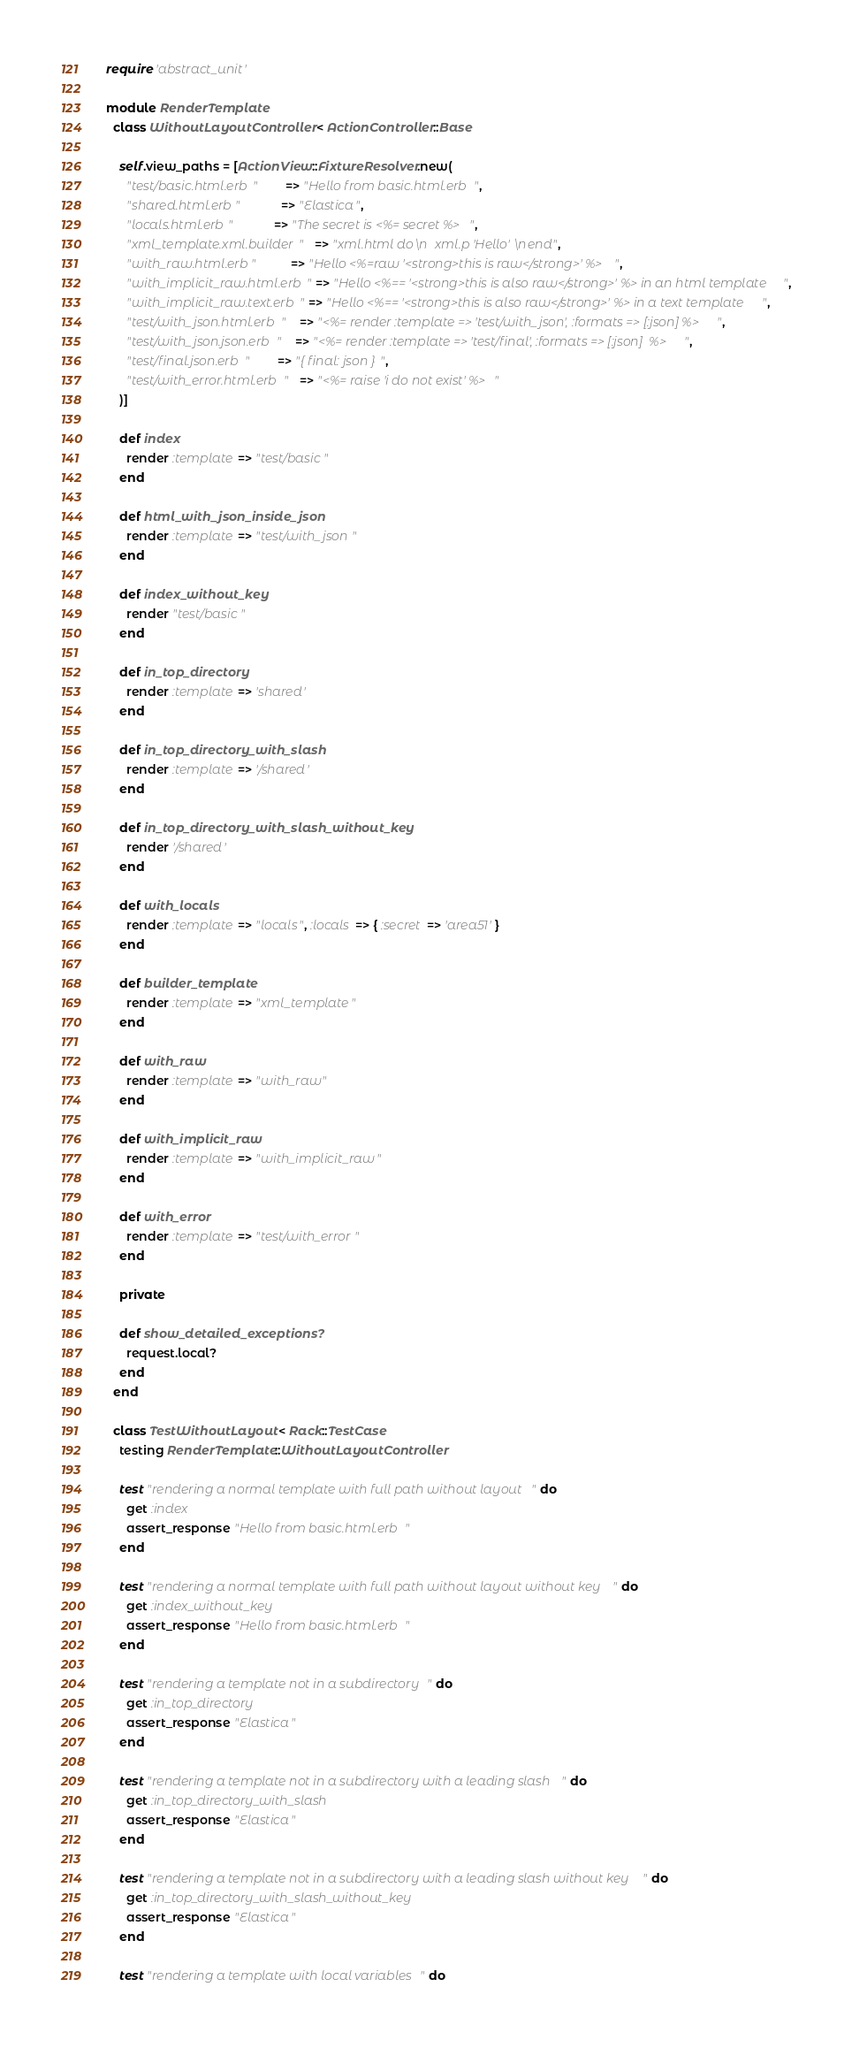<code> <loc_0><loc_0><loc_500><loc_500><_Ruby_>require 'abstract_unit'

module RenderTemplate
  class WithoutLayoutController < ActionController::Base

    self.view_paths = [ActionView::FixtureResolver.new(
      "test/basic.html.erb"        => "Hello from basic.html.erb",
      "shared.html.erb"            => "Elastica",
      "locals.html.erb"            => "The secret is <%= secret %>",
      "xml_template.xml.builder"   => "xml.html do\n  xml.p 'Hello'\nend",
      "with_raw.html.erb"          => "Hello <%=raw '<strong>this is raw</strong>' %>",
      "with_implicit_raw.html.erb" => "Hello <%== '<strong>this is also raw</strong>' %> in an html template",
      "with_implicit_raw.text.erb" => "Hello <%== '<strong>this is also raw</strong>' %> in a text template",
      "test/with_json.html.erb"    => "<%= render :template => 'test/with_json', :formats => [:json] %>",
      "test/with_json.json.erb"    => "<%= render :template => 'test/final', :formats => [:json]  %>",
      "test/final.json.erb"        => "{ final: json }",
      "test/with_error.html.erb"   => "<%= raise 'i do not exist' %>"
    )]

    def index
      render :template => "test/basic"
    end

    def html_with_json_inside_json
      render :template => "test/with_json"
    end

    def index_without_key
      render "test/basic"
    end

    def in_top_directory
      render :template => 'shared'
    end

    def in_top_directory_with_slash
      render :template => '/shared'
    end

    def in_top_directory_with_slash_without_key
      render '/shared'
    end

    def with_locals
      render :template => "locals", :locals => { :secret => 'area51' }
    end

    def builder_template
      render :template => "xml_template"
    end

    def with_raw
      render :template => "with_raw"
    end

    def with_implicit_raw
      render :template => "with_implicit_raw"
    end

    def with_error
      render :template => "test/with_error"
    end

    private

    def show_detailed_exceptions?
      request.local?
    end
  end

  class TestWithoutLayout < Rack::TestCase
    testing RenderTemplate::WithoutLayoutController

    test "rendering a normal template with full path without layout" do
      get :index
      assert_response "Hello from basic.html.erb"
    end

    test "rendering a normal template with full path without layout without key" do
      get :index_without_key
      assert_response "Hello from basic.html.erb"
    end

    test "rendering a template not in a subdirectory" do
      get :in_top_directory
      assert_response "Elastica"
    end

    test "rendering a template not in a subdirectory with a leading slash" do
      get :in_top_directory_with_slash
      assert_response "Elastica"
    end

    test "rendering a template not in a subdirectory with a leading slash without key" do
      get :in_top_directory_with_slash_without_key
      assert_response "Elastica"
    end

    test "rendering a template with local variables" do</code> 